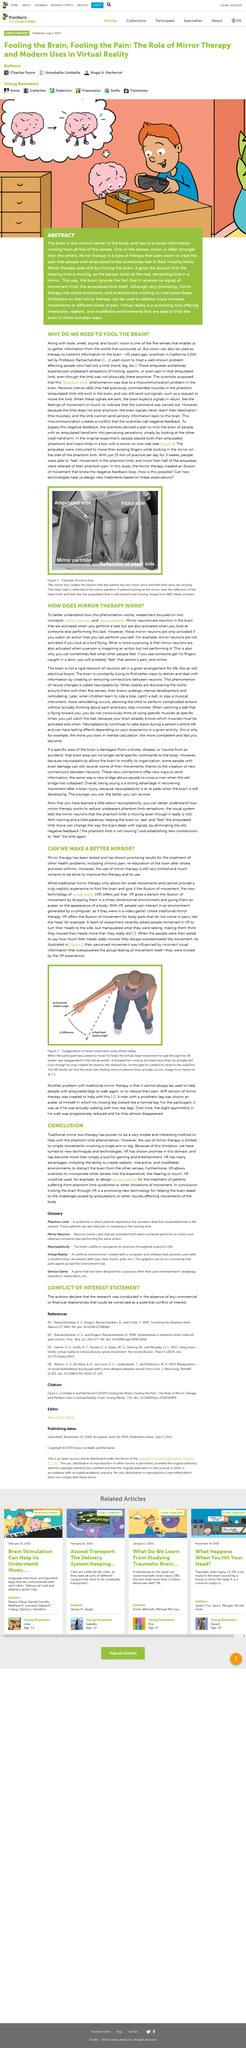Point out several critical features in this image. The researchers discovered that the phenomenon of reading and writing is mediated by two key concepts: mirror neurons and neuroplasticity. The surprising fact about mirror neurons is that they are also activated when a person is imagining an action but not performing it. Mirror neurons are only activated when an individual observes an action that they are capable of performing themselves. 